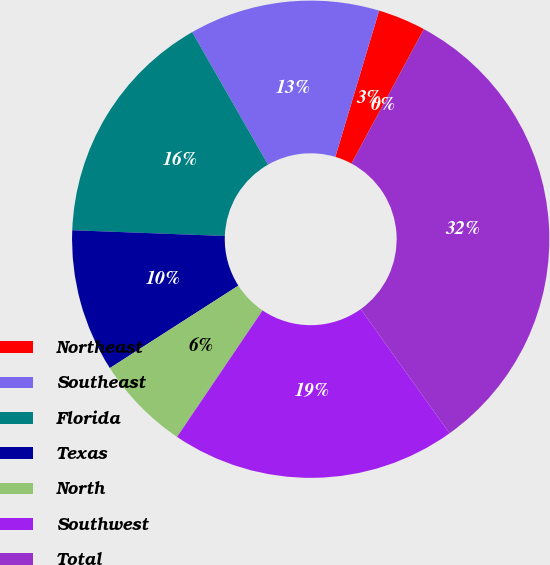<chart> <loc_0><loc_0><loc_500><loc_500><pie_chart><fcel>Northeast<fcel>Southeast<fcel>Florida<fcel>Texas<fcel>North<fcel>Southwest<fcel>Total<fcel>Developed ()<nl><fcel>3.23%<fcel>12.9%<fcel>16.13%<fcel>9.68%<fcel>6.46%<fcel>19.35%<fcel>32.25%<fcel>0.01%<nl></chart> 